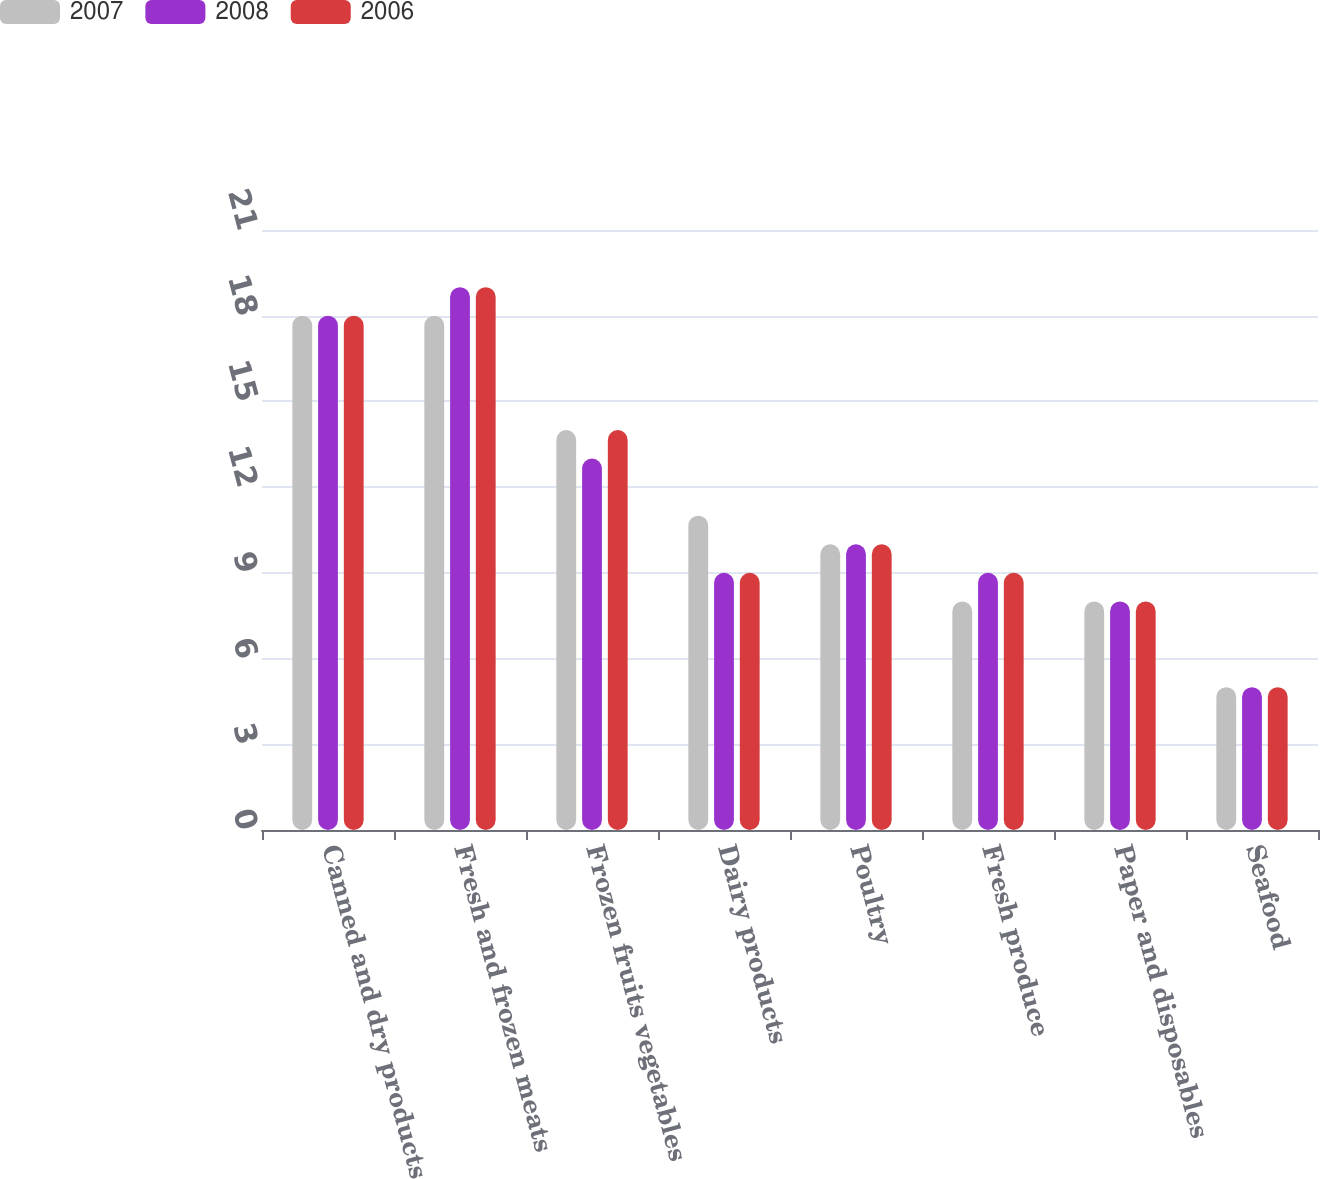<chart> <loc_0><loc_0><loc_500><loc_500><stacked_bar_chart><ecel><fcel>Canned and dry products<fcel>Fresh and frozen meats<fcel>Frozen fruits vegetables<fcel>Dairy products<fcel>Poultry<fcel>Fresh produce<fcel>Paper and disposables<fcel>Seafood<nl><fcel>2007<fcel>18<fcel>18<fcel>14<fcel>11<fcel>10<fcel>8<fcel>8<fcel>5<nl><fcel>2008<fcel>18<fcel>19<fcel>13<fcel>9<fcel>10<fcel>9<fcel>8<fcel>5<nl><fcel>2006<fcel>18<fcel>19<fcel>14<fcel>9<fcel>10<fcel>9<fcel>8<fcel>5<nl></chart> 